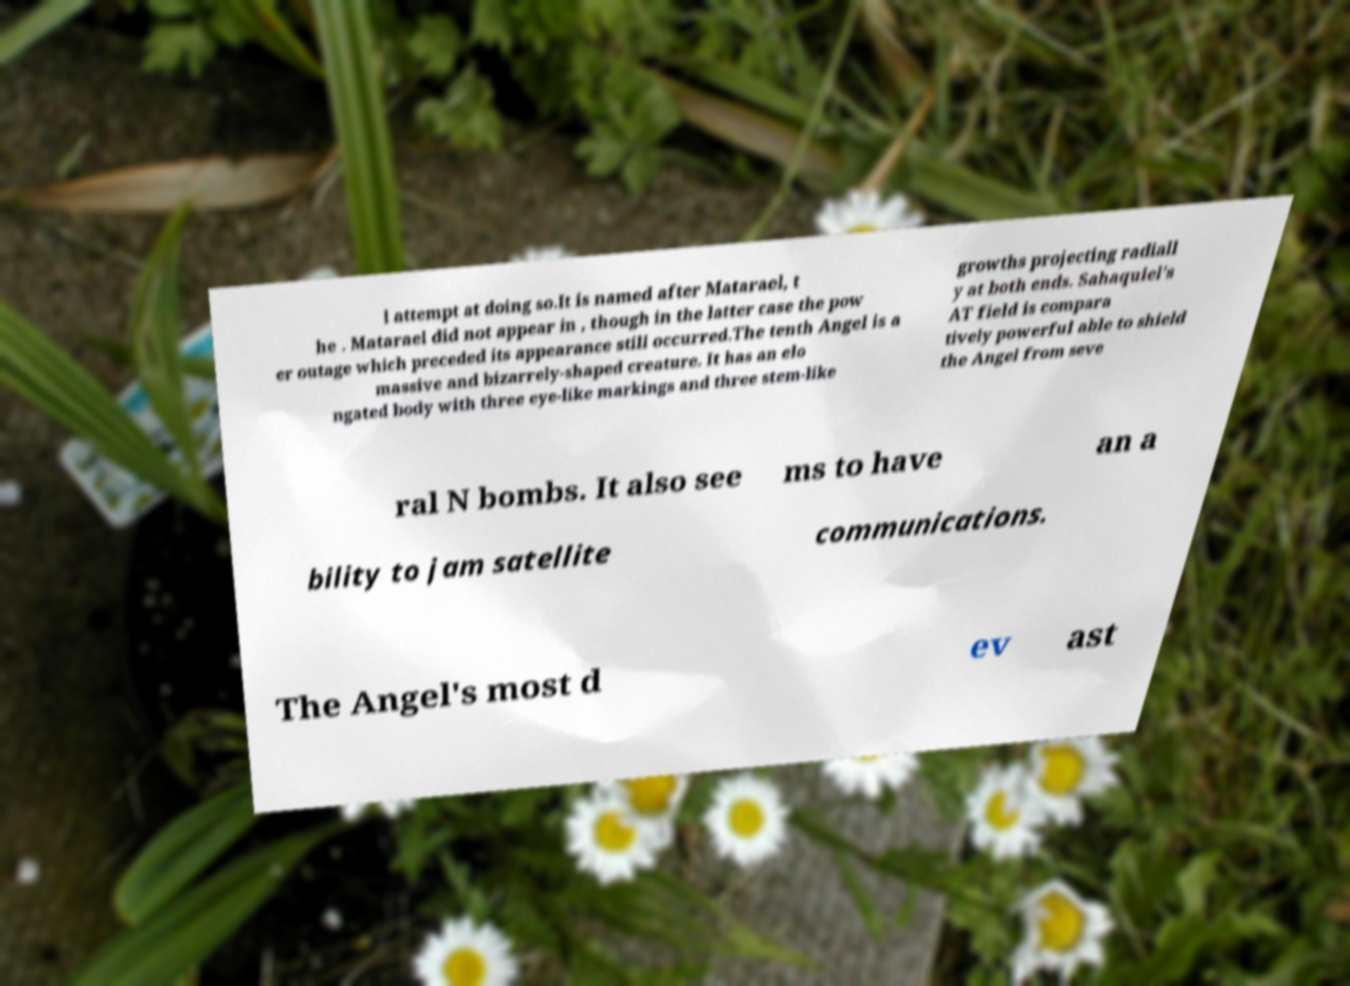Can you read and provide the text displayed in the image?This photo seems to have some interesting text. Can you extract and type it out for me? l attempt at doing so.It is named after Matarael, t he . Matarael did not appear in , though in the latter case the pow er outage which preceded its appearance still occurred.The tenth Angel is a massive and bizarrely-shaped creature. It has an elo ngated body with three eye-like markings and three stem-like growths projecting radiall y at both ends. Sahaquiel's AT field is compara tively powerful able to shield the Angel from seve ral N bombs. It also see ms to have an a bility to jam satellite communications. The Angel's most d ev ast 